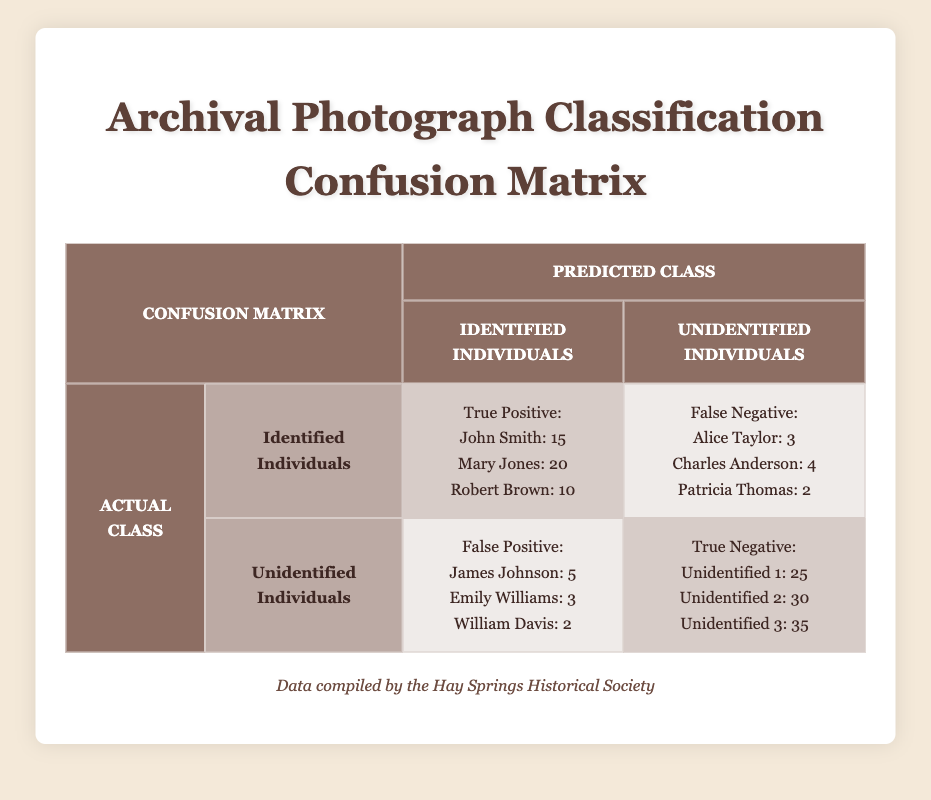What is the total number of identified individuals correctly classified? To find the total number of correctly classified identified individuals (true positives), we add the values for John Smith, Mary Jones, and Robert Brown: 15 + 20 + 10 = 45.
Answer: 45 What is the total number of unidentified individuals correctly classified? The total number of unidentified individuals correctly classified (true negatives) is the sum of Unidentified 1, Unidentified 2, and Unidentified 3: 25 + 30 + 35 = 90.
Answer: 90 How many individuals were incorrectly identified as unidentified? The total number of falsely identified individuals (false positives) is the sum of the false positive counts: 5 (James Johnson) + 3 (Emily Williams) + 2 (William Davis) = 10.
Answer: 10 Were there any individuals who were incorrectly classified as identified? Yes. The data shows the number of false negatives: Alice Taylor (3), Charles Anderson (4), and Patricia Thomas (2), indicating individuals who were actually identified but classified as unidentified.
Answer: Yes What is the ratio of true positives to false negatives? To find the ratio, combine the true positive counts (15 + 20 + 10 = 45) and the false negative counts (3 + 4 + 2 = 9). The ratio then is 45:9, which simplifies to 5:1.
Answer: 5:1 What percentage of identified individuals were classified correctly? The percentage can be calculated by dividing the true positives (45) by the actual identified individuals (true positives + false negatives = 45 + 9 = 54) and then multiplying by 100: (45 / 54) * 100 ≈ 83.33%.
Answer: 83.33% How many unidentified individuals were misclassified as identified? To find the total number of identified individuals misclassified as unidentified, sum the false positives: 5 (James Johnson) + 3 (Emily Williams) + 2 (William Davis) = 10.
Answer: 10 What is the total number of photographs reviewed? To find the total, add true positives, false positives, true negatives, and false negatives together: 45 (true positives) + 10 (false positives) + 90 (true negatives) + 9 (false negatives) = 154.
Answer: 154 How many individuals were classified correctly in total? To find the total correctly classified individuals, add true positives (45) and true negatives (90): 45 + 90 = 135.
Answer: 135 